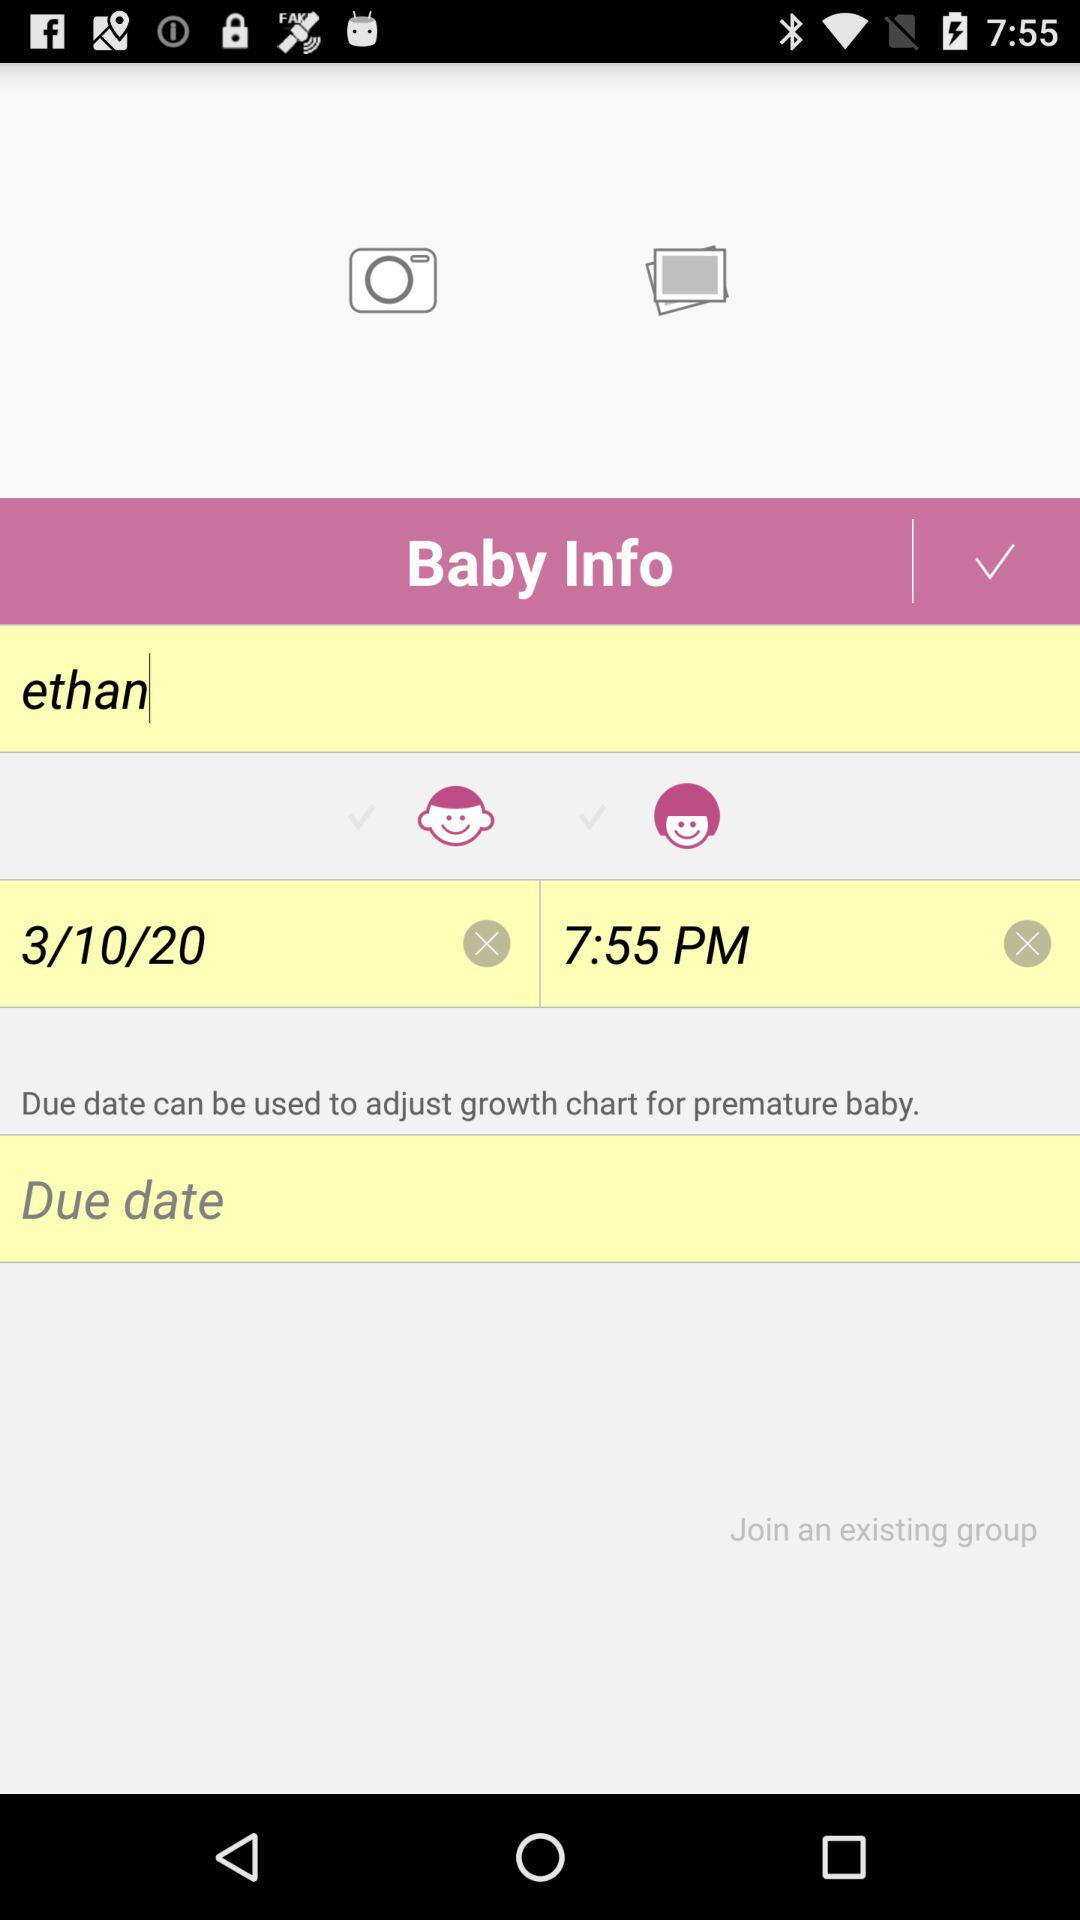What is the given date? The given date is March 10, 2020. 